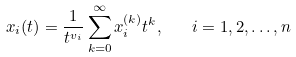Convert formula to latex. <formula><loc_0><loc_0><loc_500><loc_500>x _ { i } ( t ) = \frac { 1 } { t ^ { v _ { i } } } \sum _ { k = 0 } ^ { \infty } x _ { i } ^ { ( k ) } t ^ { k } , \quad i = 1 , 2 , \dots , n</formula> 